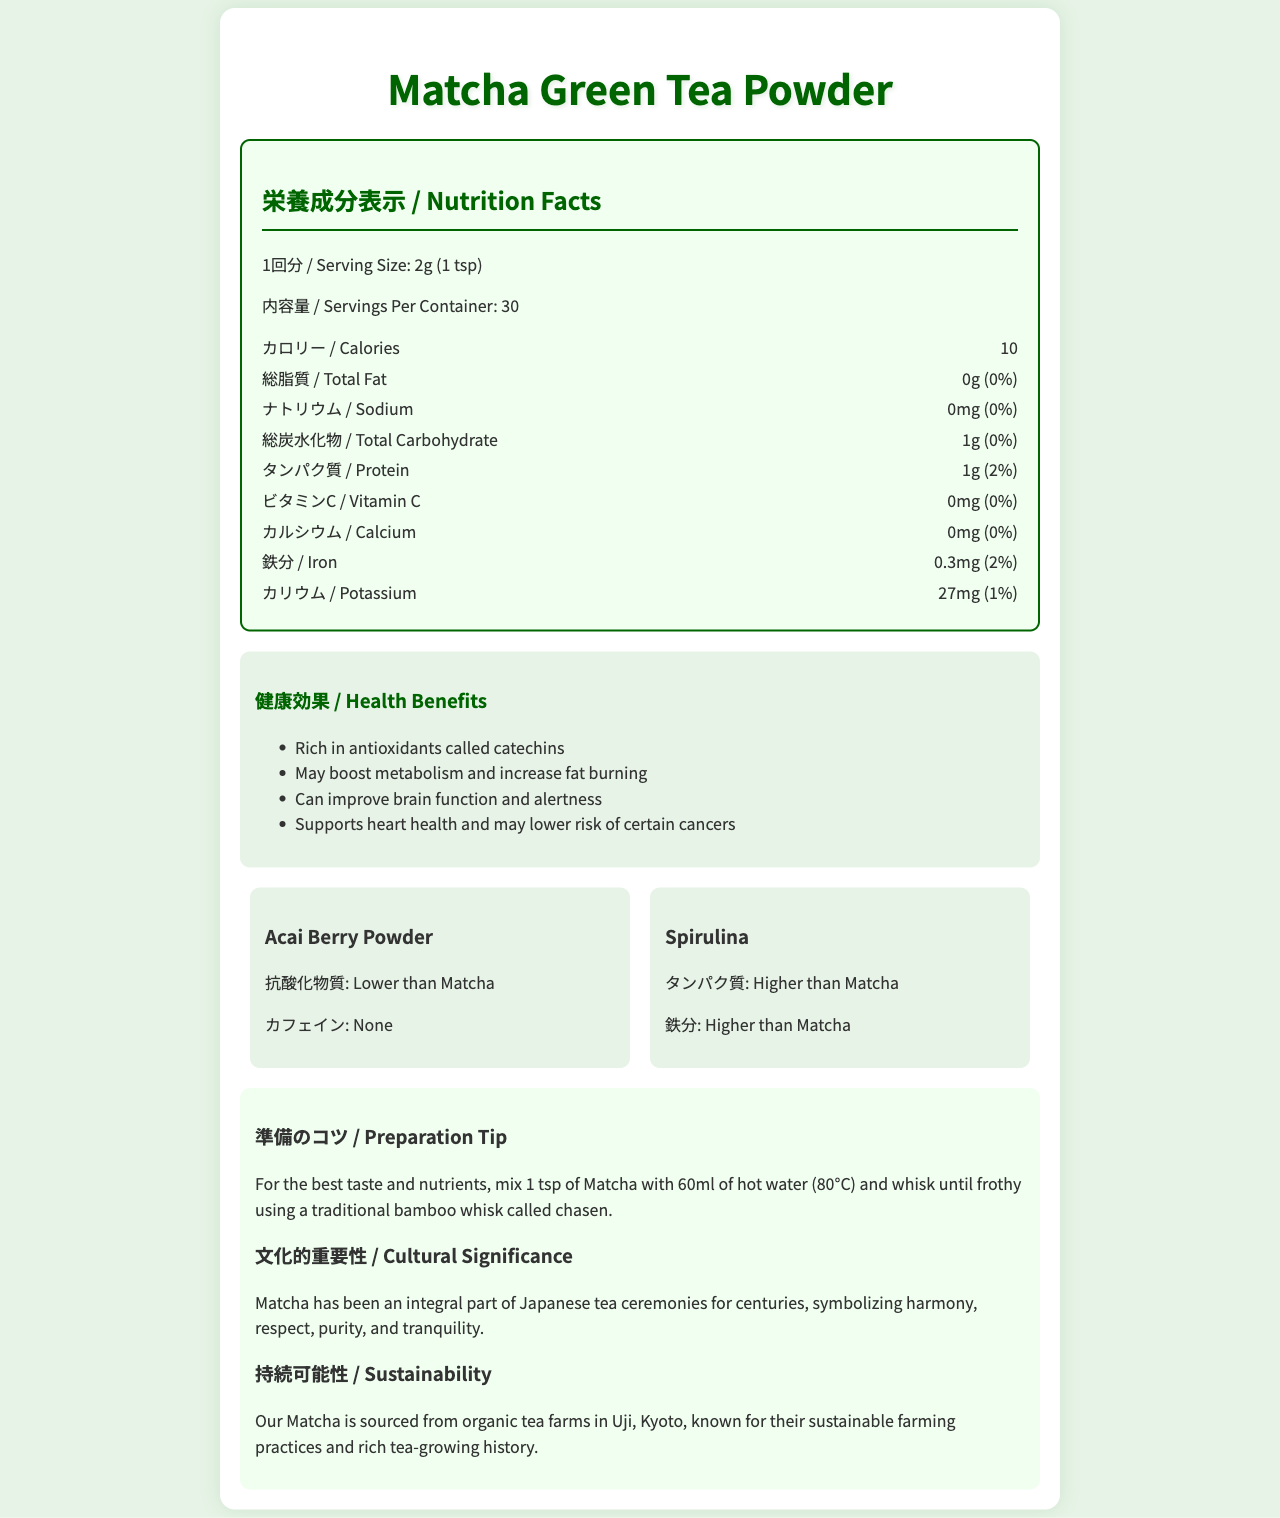what is the serving size of Matcha Green Tea Powder? The serving size is clearly specified in the document as 2g (1 tsp).
Answer: 2g (1 tsp) how many servings per container are there for the Matcha Green Tea Powder? The document indicates that the package contains 30 servings.
Answer: 30 how many calories are there in one serving of Matcha Green Tea Powder? The document lists 10 calories per serving in the nutrition section.
Answer: 10 what is the total carbohydrate content in one serving? According to the nutrition facts, the total carbohydrate content per serving is 1g.
Answer: 1g how much iron does one serving of Matcha provide? The document shows that the iron content per serving is 0.3mg.
Answer: 0.3mg which superfood contains no caffeine? A. Matcha Green Tea Powder B. Acai Berry Powder C. Spirulina The comparison section of the document notes that Acai Berry Powder contains no caffeine.
Answer: B which superfood has the highest protein content? I. Matcha Green Tea Powder II. Acai Berry Powder III. Spirulina The comparison section details that Spirulina has a higher protein content than Matcha Green Tea Powder and Acai Berry Powder.
Answer: III True or False: Matcha Green Tea Powder has calcium in it. According to the nutritional information, Matcha Green Tea Powder contains 0mg of calcium.
Answer: False summarize the health benefits provided by Matcha Green Tea Powder. The document lists several health benefits: it is rich in antioxidants called catechins, may boost metabolism and increase fat burning, can improve brain function and alertness, supports heart health, and may lower the risk of certain cancers.
Answer: Rich in antioxidants (catechins), boosts metabolism, improves brain function, supports heart health, may reduce cancer risk where is the Matcha Green Tea Powder sourced from? The sustainability section specifies that the Matcha is sourced from organic tea farms in Uji, Kyoto.
Answer: Uji, Kyoto does the document mention the exact harvest season for the Matcha leaves? The document does not provide details about the exact harvest season for Matcha leaves.
Answer: Not enough information what cultural significance does Matcha have in Japan? The cultural significance section explains that Matcha has been integral to Japanese tea ceremonies, symbolizing harmony, respect, purity, and tranquility.
Answer: Symbolizes harmony, respect, purity, and tranquility in Japanese tea ceremonies how should you prepare Matcha for the best taste and nutrients? The preparation tip section provides a detailed method for preparing Matcha for the best taste and nutrients.
Answer: Mix 1 tsp of Matcha with 60ml of hot water (80°C) and whisk until frothy using a traditional bamboo whisk called chasen 